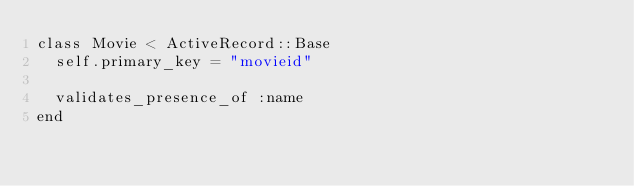<code> <loc_0><loc_0><loc_500><loc_500><_Ruby_>class Movie < ActiveRecord::Base
  self.primary_key = "movieid"

  validates_presence_of :name
end
</code> 